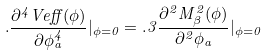Convert formula to latex. <formula><loc_0><loc_0><loc_500><loc_500>. \frac { \partial ^ { 4 } V e f f ( \phi ) } { \partial \phi _ { a } ^ { 4 } } | _ { \phi = 0 } = . 3 \frac { \partial ^ { 2 } M _ { \beta } ^ { 2 } ( \phi ) } { \partial ^ { 2 } \phi _ { a } } | _ { \phi = 0 }</formula> 